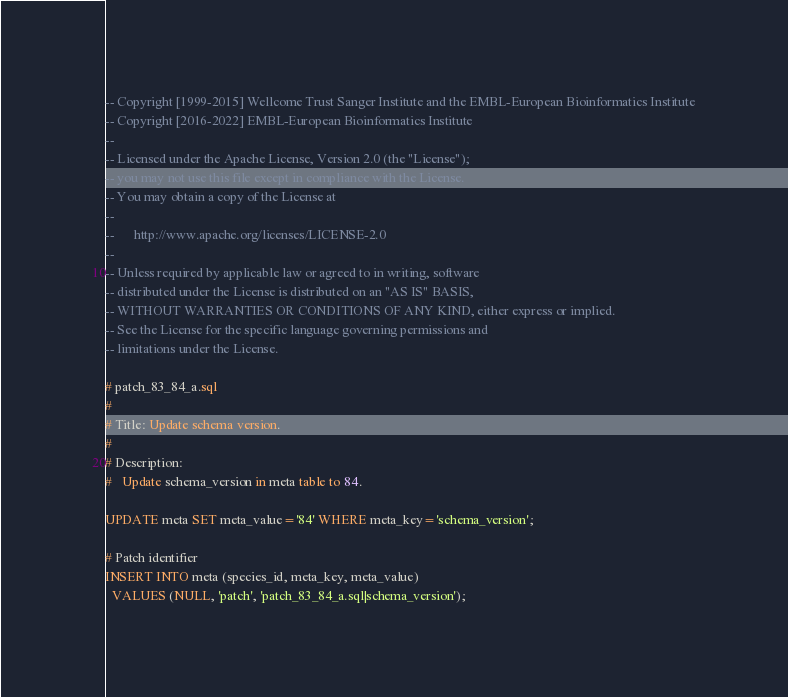Convert code to text. <code><loc_0><loc_0><loc_500><loc_500><_SQL_>-- Copyright [1999-2015] Wellcome Trust Sanger Institute and the EMBL-European Bioinformatics Institute
-- Copyright [2016-2022] EMBL-European Bioinformatics Institute
-- 
-- Licensed under the Apache License, Version 2.0 (the "License");
-- you may not use this file except in compliance with the License.
-- You may obtain a copy of the License at
-- 
--      http://www.apache.org/licenses/LICENSE-2.0
-- 
-- Unless required by applicable law or agreed to in writing, software
-- distributed under the License is distributed on an "AS IS" BASIS,
-- WITHOUT WARRANTIES OR CONDITIONS OF ANY KIND, either express or implied.
-- See the License for the specific language governing permissions and
-- limitations under the License.

# patch_83_84_a.sql
#
# Title: Update schema version.
#
# Description:
#   Update schema_version in meta table to 84.

UPDATE meta SET meta_value='84' WHERE meta_key='schema_version';

# Patch identifier
INSERT INTO meta (species_id, meta_key, meta_value)
  VALUES (NULL, 'patch', 'patch_83_84_a.sql|schema_version');
</code> 